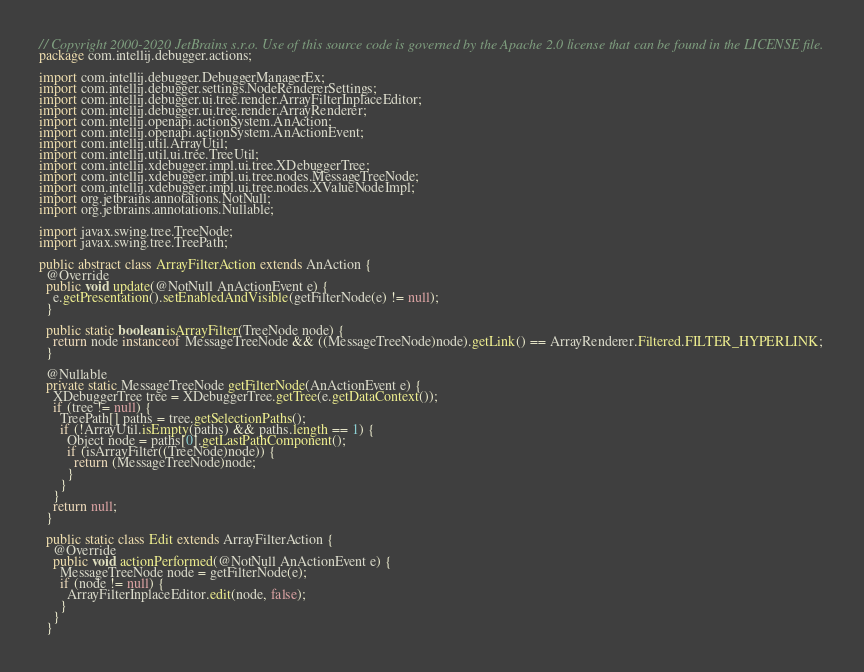<code> <loc_0><loc_0><loc_500><loc_500><_Java_>// Copyright 2000-2020 JetBrains s.r.o. Use of this source code is governed by the Apache 2.0 license that can be found in the LICENSE file.
package com.intellij.debugger.actions;

import com.intellij.debugger.DebuggerManagerEx;
import com.intellij.debugger.settings.NodeRendererSettings;
import com.intellij.debugger.ui.tree.render.ArrayFilterInplaceEditor;
import com.intellij.debugger.ui.tree.render.ArrayRenderer;
import com.intellij.openapi.actionSystem.AnAction;
import com.intellij.openapi.actionSystem.AnActionEvent;
import com.intellij.util.ArrayUtil;
import com.intellij.util.ui.tree.TreeUtil;
import com.intellij.xdebugger.impl.ui.tree.XDebuggerTree;
import com.intellij.xdebugger.impl.ui.tree.nodes.MessageTreeNode;
import com.intellij.xdebugger.impl.ui.tree.nodes.XValueNodeImpl;
import org.jetbrains.annotations.NotNull;
import org.jetbrains.annotations.Nullable;

import javax.swing.tree.TreeNode;
import javax.swing.tree.TreePath;

public abstract class ArrayFilterAction extends AnAction {
  @Override
  public void update(@NotNull AnActionEvent e) {
    e.getPresentation().setEnabledAndVisible(getFilterNode(e) != null);
  }

  public static boolean isArrayFilter(TreeNode node) {
    return node instanceof MessageTreeNode && ((MessageTreeNode)node).getLink() == ArrayRenderer.Filtered.FILTER_HYPERLINK;
  }

  @Nullable
  private static MessageTreeNode getFilterNode(AnActionEvent e) {
    XDebuggerTree tree = XDebuggerTree.getTree(e.getDataContext());
    if (tree != null) {
      TreePath[] paths = tree.getSelectionPaths();
      if (!ArrayUtil.isEmpty(paths) && paths.length == 1) {
        Object node = paths[0].getLastPathComponent();
        if (isArrayFilter((TreeNode)node)) {
          return (MessageTreeNode)node;
        }
      }
    }
    return null;
  }

  public static class Edit extends ArrayFilterAction {
    @Override
    public void actionPerformed(@NotNull AnActionEvent e) {
      MessageTreeNode node = getFilterNode(e);
      if (node != null) {
        ArrayFilterInplaceEditor.edit(node, false);
      }
    }
  }
</code> 